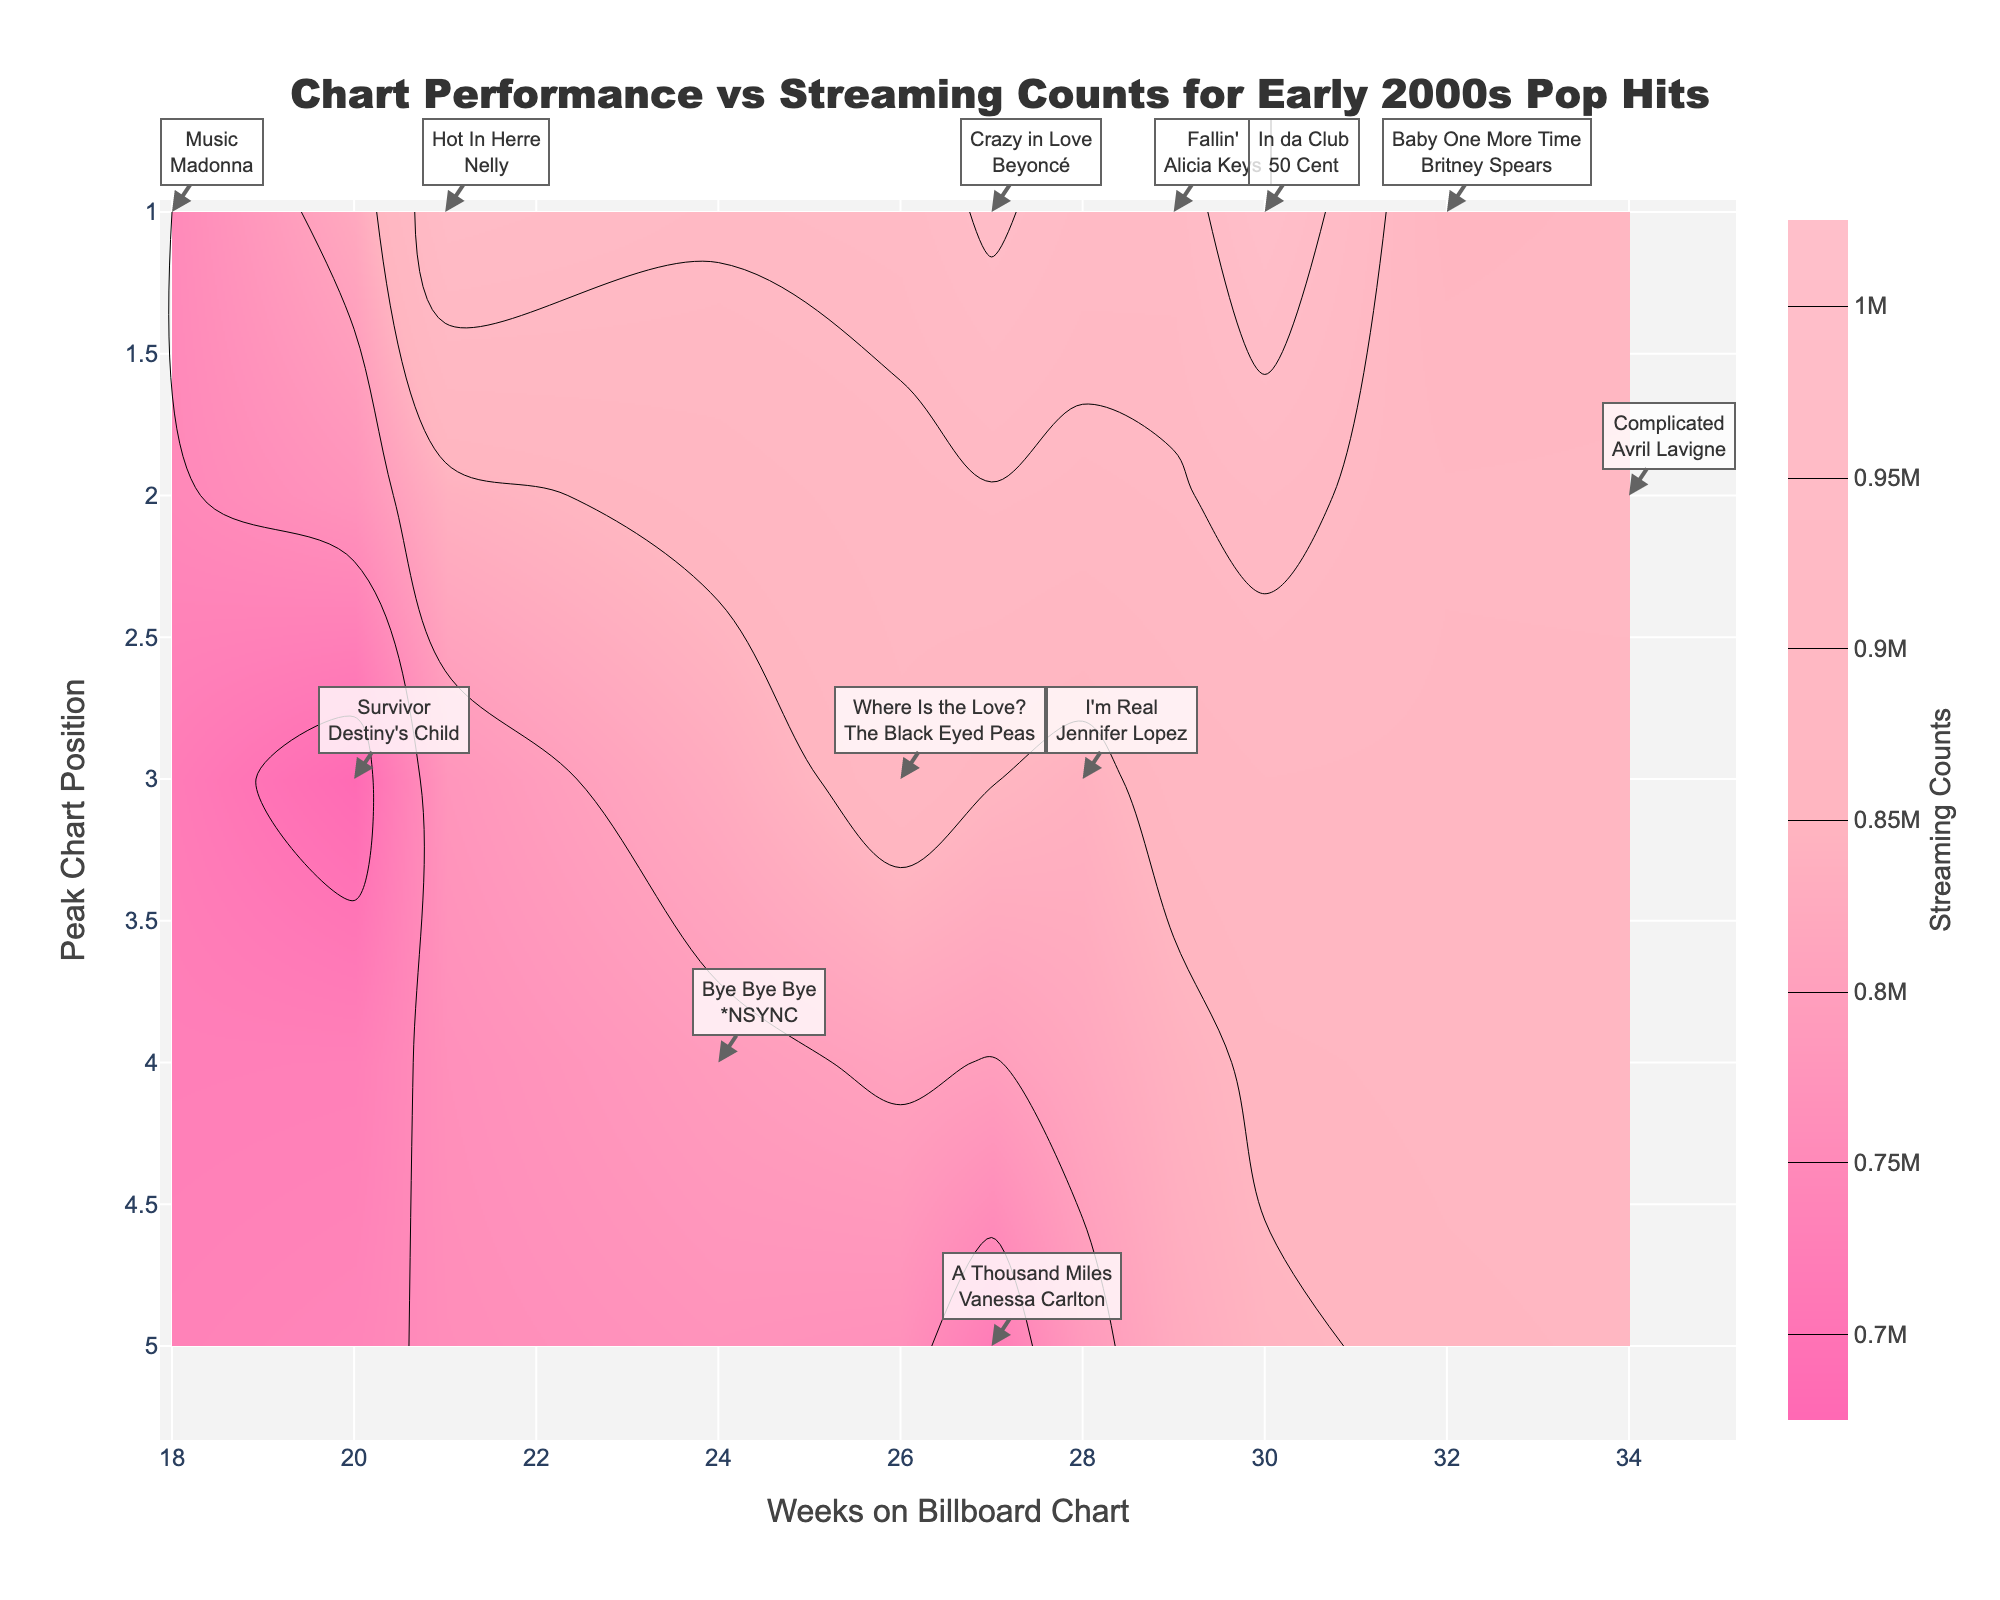What is the title of the plot? The title of the plot is usually found at the top of the figure. It helps understand the main topic the plot represents. In this case, the plot's title states the main analysis focus.
Answer: Chart Performance vs Streaming Counts for Early 2000s Pop Hits How many songs peaked at position 1 on the chart? To find the number of songs that peaked at position 1, locate the y-axis values where "Peak Chart Position" is 1 and count the corresponding data points. According to the labels, identify and sum up all such songs.
Answer: 6 Which song has the highest streaming counts, and how can we tell? Look for the highest values in the 'Streaming Counts' color bar or the annotations on the graph. In this case, you should identify the data point that corresponds to 1,000,000 in streaming counts and check the label.
Answer: In da Club by 50 Cent Which song had the longest stay on the Billboard Chart? To find this, identify the song with the highest "Billboard_Weeks" on the x-axis. Check the corresponding annotation or label of that data point to determine the specific song.
Answer: Complicated by Avril Lavigne What color represents the lowest streaming counts in the plot, and what is that value? Identify the color associated with the lowest streaming values by observing the contour plot's color scale. The legend shows the spectrum of colors tied to specific streaming counts.
Answer: Hot Pink, 700000 Compare the streaming counts for "Hot In Herre" by Nelly and "A Thousand Miles" by Vanessa Carlton. Which song had more streams? To compare, locate both songs on the plot, check their streaming counts either through the annotations or color scale, and determine which is higher.
Answer: Hot In Herre by Nelly What is the average streaming count for songs with a peak chart position of 1? First, list the streaming counts for songs peaking at position 1, then calculate the average. This involves summing all streaming counts and dividing by the number of songs.
Answer: (850000 + 750000 + 920000 + 940000 + 960000 + 1000000)/6 = 902000 Which artist appears most frequently in the top chart positions? By scanning through the plot annotations, count the number of times each artist has a song with a peak chart position of 1. Determine the artist with the highest count.
Answer: Britney Spears Is there any correlation between the number of weeks on the Billboard Chart and the streaming counts? To identify a correlation, observe the pattern formed by the data points and contour lines. If higher streaming counts are usually associated with more weeks on the Billboard, there is likely a positive correlation.
Answer: Yes, likely positive 